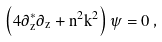Convert formula to latex. <formula><loc_0><loc_0><loc_500><loc_500>\left ( 4 \partial _ { z } ^ { * } \partial _ { z } + n ^ { 2 } k ^ { 2 } \right ) \psi = 0 \, ,</formula> 